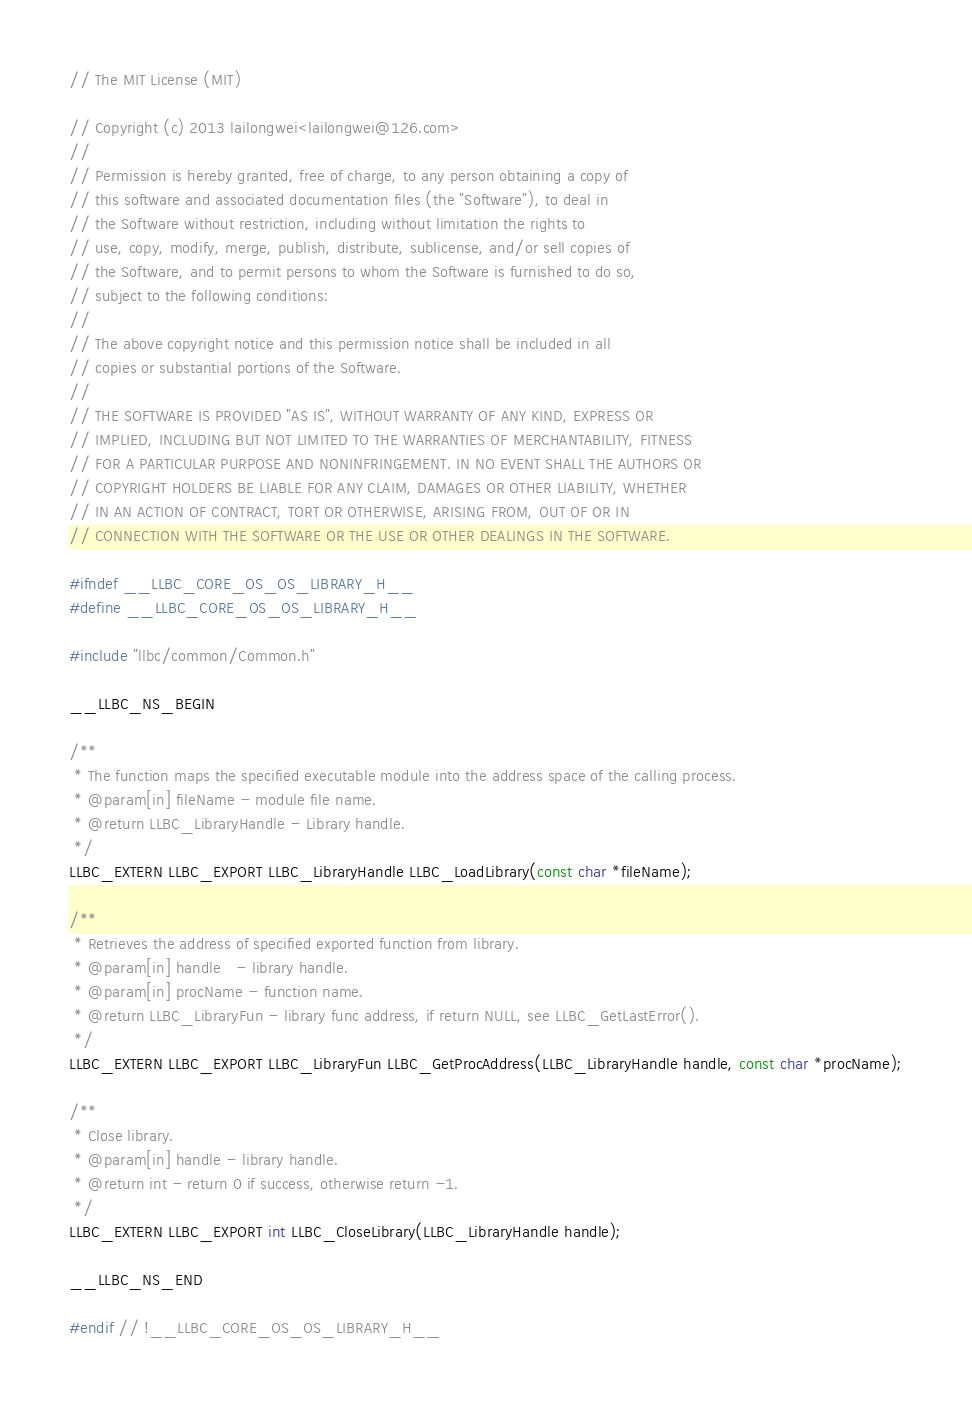<code> <loc_0><loc_0><loc_500><loc_500><_C_>// The MIT License (MIT)

// Copyright (c) 2013 lailongwei<lailongwei@126.com>
// 
// Permission is hereby granted, free of charge, to any person obtaining a copy of 
// this software and associated documentation files (the "Software"), to deal in 
// the Software without restriction, including without limitation the rights to 
// use, copy, modify, merge, publish, distribute, sublicense, and/or sell copies of 
// the Software, and to permit persons to whom the Software is furnished to do so, 
// subject to the following conditions:
// 
// The above copyright notice and this permission notice shall be included in all 
// copies or substantial portions of the Software.
// 
// THE SOFTWARE IS PROVIDED "AS IS", WITHOUT WARRANTY OF ANY KIND, EXPRESS OR 
// IMPLIED, INCLUDING BUT NOT LIMITED TO THE WARRANTIES OF MERCHANTABILITY, FITNESS 
// FOR A PARTICULAR PURPOSE AND NONINFRINGEMENT. IN NO EVENT SHALL THE AUTHORS OR 
// COPYRIGHT HOLDERS BE LIABLE FOR ANY CLAIM, DAMAGES OR OTHER LIABILITY, WHETHER 
// IN AN ACTION OF CONTRACT, TORT OR OTHERWISE, ARISING FROM, OUT OF OR IN 
// CONNECTION WITH THE SOFTWARE OR THE USE OR OTHER DEALINGS IN THE SOFTWARE.

#ifndef __LLBC_CORE_OS_OS_LIBRARY_H__
#define __LLBC_CORE_OS_OS_LIBRARY_H__

#include "llbc/common/Common.h"

__LLBC_NS_BEGIN

/**
 * The function maps the specified executable module into the address space of the calling process.
 * @param[in] fileName - module file name.
 * @return LLBC_LibraryHandle - Library handle.
 */
LLBC_EXTERN LLBC_EXPORT LLBC_LibraryHandle LLBC_LoadLibrary(const char *fileName);

/**
 * Retrieves the address of specified exported function from library.
 * @param[in] handle   - library handle.
 * @param[in] procName - function name.
 * @return LLBC_LibraryFun - library func address, if return NULL, see LLBC_GetLastError().
 */
LLBC_EXTERN LLBC_EXPORT LLBC_LibraryFun LLBC_GetProcAddress(LLBC_LibraryHandle handle, const char *procName);

/**
 * Close library.
 * @param[in] handle - library handle.
 * @return int - return 0 if success, otherwise return -1.
 */
LLBC_EXTERN LLBC_EXPORT int LLBC_CloseLibrary(LLBC_LibraryHandle handle);

__LLBC_NS_END

#endif // !__LLBC_CORE_OS_OS_LIBRARY_H__
</code> 